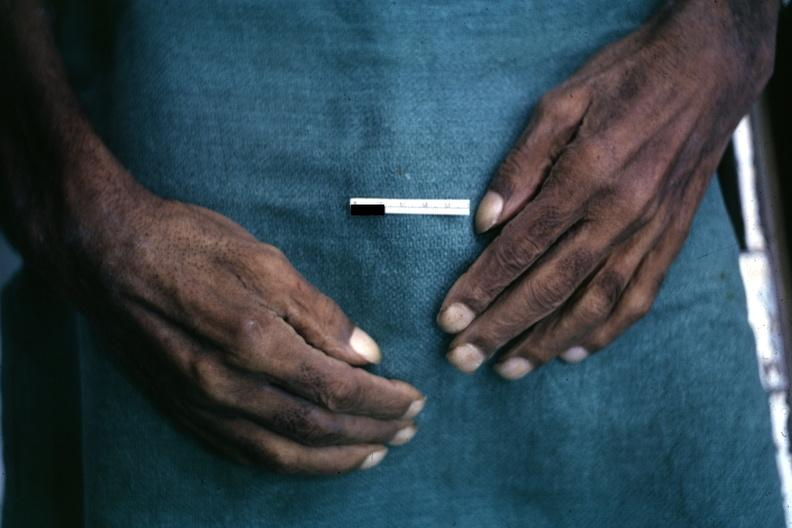what is present?
Answer the question using a single word or phrase. Pulmonary osteoarthropathy 